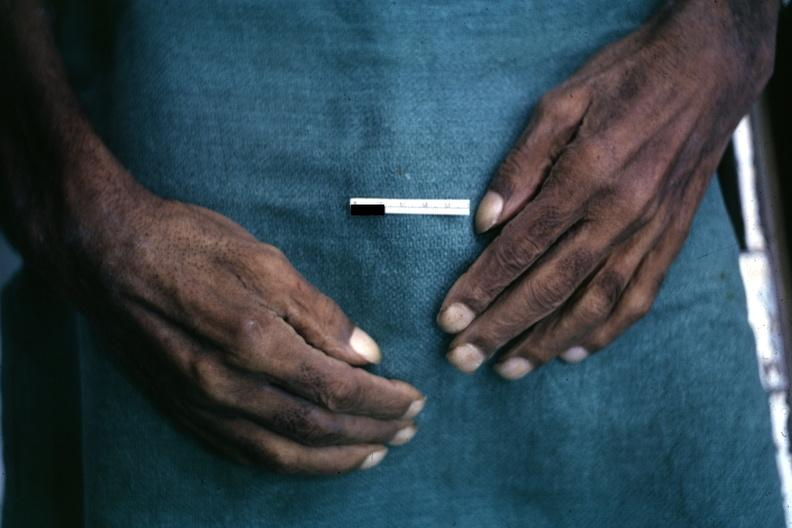what is present?
Answer the question using a single word or phrase. Pulmonary osteoarthropathy 